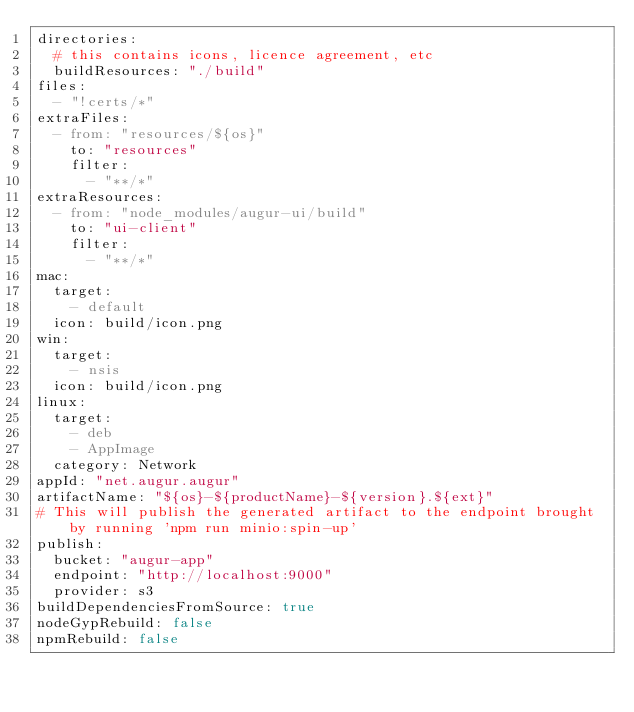<code> <loc_0><loc_0><loc_500><loc_500><_YAML_>directories:
  # this contains icons, licence agreement, etc
  buildResources: "./build"
files:
  - "!certs/*"
extraFiles:
  - from: "resources/${os}"
    to: "resources"
    filter:
      - "**/*"
extraResources:
  - from: "node_modules/augur-ui/build"
    to: "ui-client"
    filter:
      - "**/*"
mac:
  target:
    - default
  icon: build/icon.png
win:
  target:
    - nsis
  icon: build/icon.png
linux:
  target:
    - deb
    - AppImage
  category: Network
appId: "net.augur.augur"
artifactName: "${os}-${productName}-${version}.${ext}"
# This will publish the generated artifact to the endpoint brought by running 'npm run minio:spin-up'
publish:
  bucket: "augur-app"
  endpoint: "http://localhost:9000"
  provider: s3
buildDependenciesFromSource: true
nodeGypRebuild: false
npmRebuild: false
</code> 